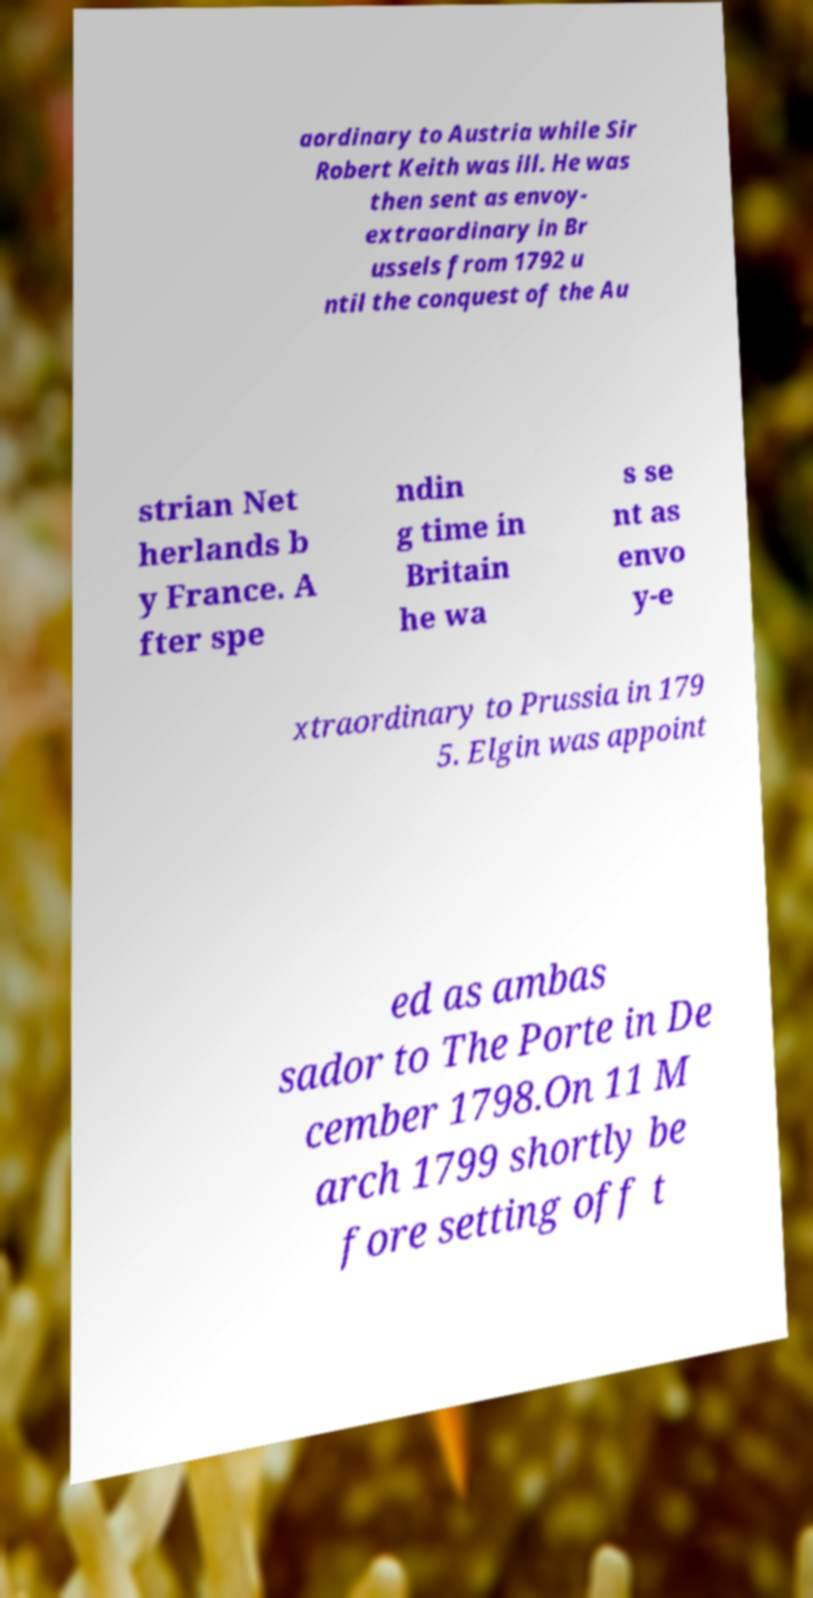Please identify and transcribe the text found in this image. aordinary to Austria while Sir Robert Keith was ill. He was then sent as envoy- extraordinary in Br ussels from 1792 u ntil the conquest of the Au strian Net herlands b y France. A fter spe ndin g time in Britain he wa s se nt as envo y-e xtraordinary to Prussia in 179 5. Elgin was appoint ed as ambas sador to The Porte in De cember 1798.On 11 M arch 1799 shortly be fore setting off t 